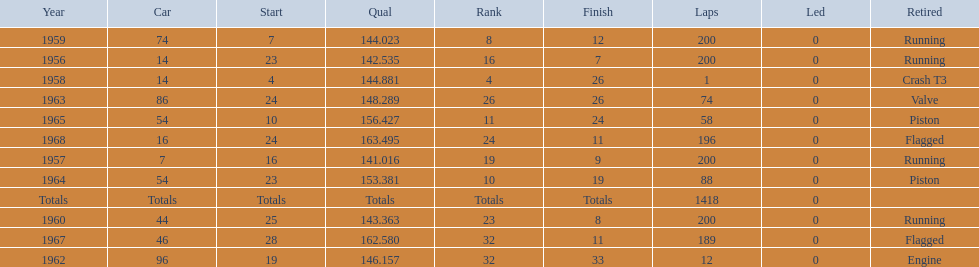Did bob veith drive more indy 500 laps in the 1950s or 1960s? 1960s. 